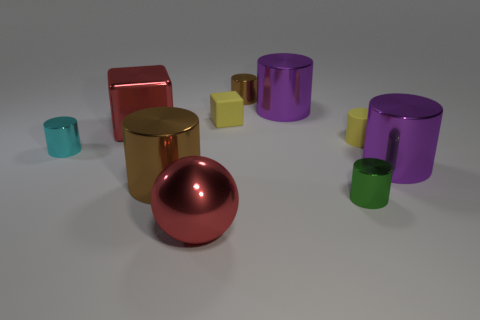Are there an equal number of yellow matte blocks on the left side of the big brown metallic object and green shiny objects that are to the right of the big red metallic ball?
Make the answer very short. No. What is the shape of the big purple object that is to the left of the purple metal thing in front of the tiny rubber thing that is to the left of the small yellow rubber cylinder?
Make the answer very short. Cylinder. Are the big object to the left of the large brown object and the tiny yellow thing that is to the left of the green cylinder made of the same material?
Your answer should be compact. No. What is the shape of the small yellow rubber object that is on the left side of the tiny green shiny thing?
Ensure brevity in your answer.  Cube. Is the number of brown metallic cylinders less than the number of red balls?
Offer a terse response. No. There is a tiny cylinder to the left of the brown metallic thing in front of the yellow cube; are there any big brown cylinders that are behind it?
Offer a terse response. No. What number of metal objects are tiny gray cylinders or big cubes?
Your response must be concise. 1. Is the color of the small matte cube the same as the large metallic cube?
Provide a succinct answer. No. What number of brown shiny objects are behind the small rubber block?
Give a very brief answer. 1. How many objects are both left of the yellow rubber cylinder and on the right side of the tiny cyan cylinder?
Offer a terse response. 7. 